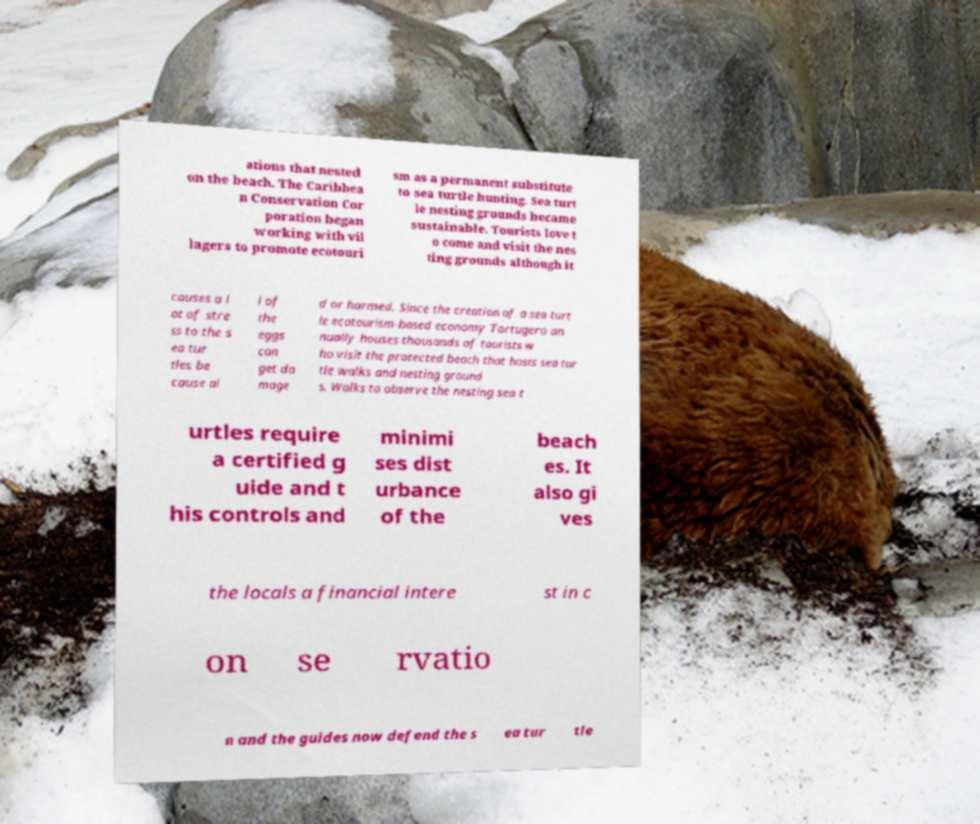Could you extract and type out the text from this image? ations that nested on the beach. The Caribbea n Conservation Cor poration began working with vil lagers to promote ecotouri sm as a permanent substitute to sea turtle hunting. Sea turt le nesting grounds became sustainable. Tourists love t o come and visit the nes ting grounds although it causes a l ot of stre ss to the s ea tur tles be cause al l of the eggs can get da mage d or harmed. Since the creation of a sea turt le ecotourism-based economy Tortugero an nually houses thousands of tourists w ho visit the protected beach that hosts sea tur tle walks and nesting ground s. Walks to observe the nesting sea t urtles require a certified g uide and t his controls and minimi ses dist urbance of the beach es. It also gi ves the locals a financial intere st in c on se rvatio n and the guides now defend the s ea tur tle 